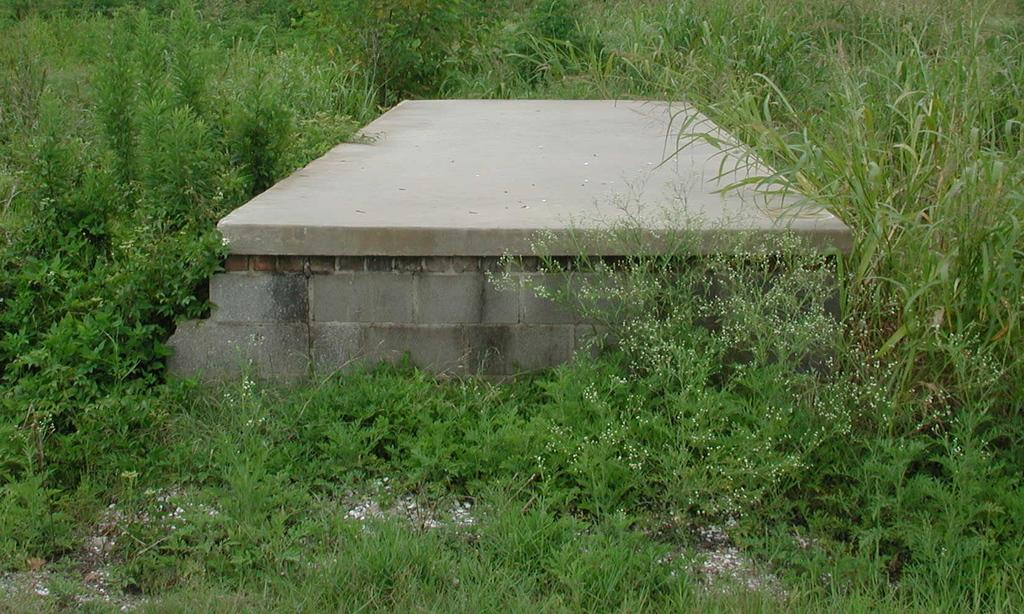What type of seating is visible in the image? There is a cement bench in the image. What type of vegetation is present around the bench? There is grass surrounding the bench. What type of wilderness can be seen in the background of the image? There is no wilderness visible in the image; it only shows a cement bench and grass. Can you see any bananas on the bench in the image? There are no bananas present in the image. 